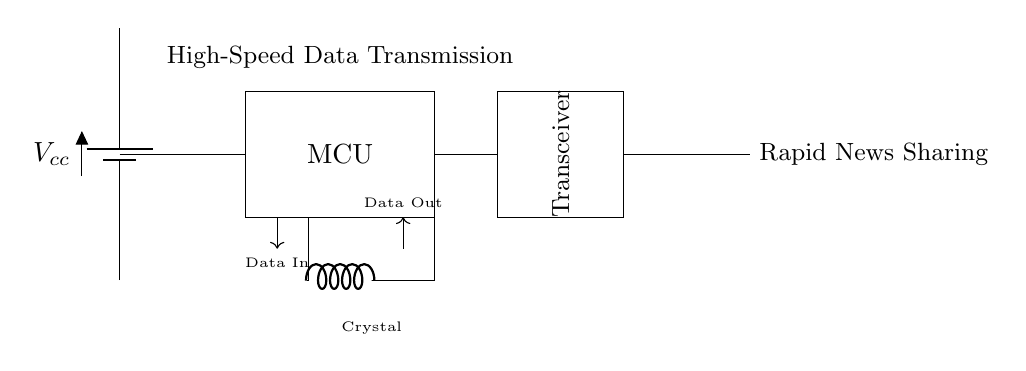What is the power supply used in the circuit? The power supply is indicated by the "battery" symbol labeled as Vcc at the left side of the circuit, which provides the necessary voltage for operation.
Answer: Vcc What component is responsible for data transmission? The high-speed transceiver, represented by a rectangular component labeled "Transceiver," facilitates data transmission within the circuit, enabling rapid sharing of news.
Answer: Transceiver How many main functional components are present in the circuit? The circuit features four main functional components: the power supply (battery), microcontroller (MCU), high-speed transceiver, and crystal oscillator. Each plays a distinct role in data processing and communication.
Answer: Four What does the crystal in the circuit do? The crystal, labeled as "Crystal" in the diagram, functions as a frequency reference for the oscillator, ensuring stable timing for data transmission in the transceiver.
Answer: Frequency reference What connects the microcontroller to the transceiver? The connection from the microcontroller to the transceiver is represented by a line between the two components, indicating a direct link for data exchange.
Answer: Data line Which component ensures stable data operation in the circuit? The crystal oscillator ensures stable operation by providing a consistent frequency signal, which is crucial for synchronization in the data transmission process.
Answer: Crystal oscillator What is the purpose of the antenna in this circuit? The antenna is designed to enable wireless communication by transmitting and receiving data signals, enhancing the rapid sharing of news over a distance.
Answer: Wireless communication 